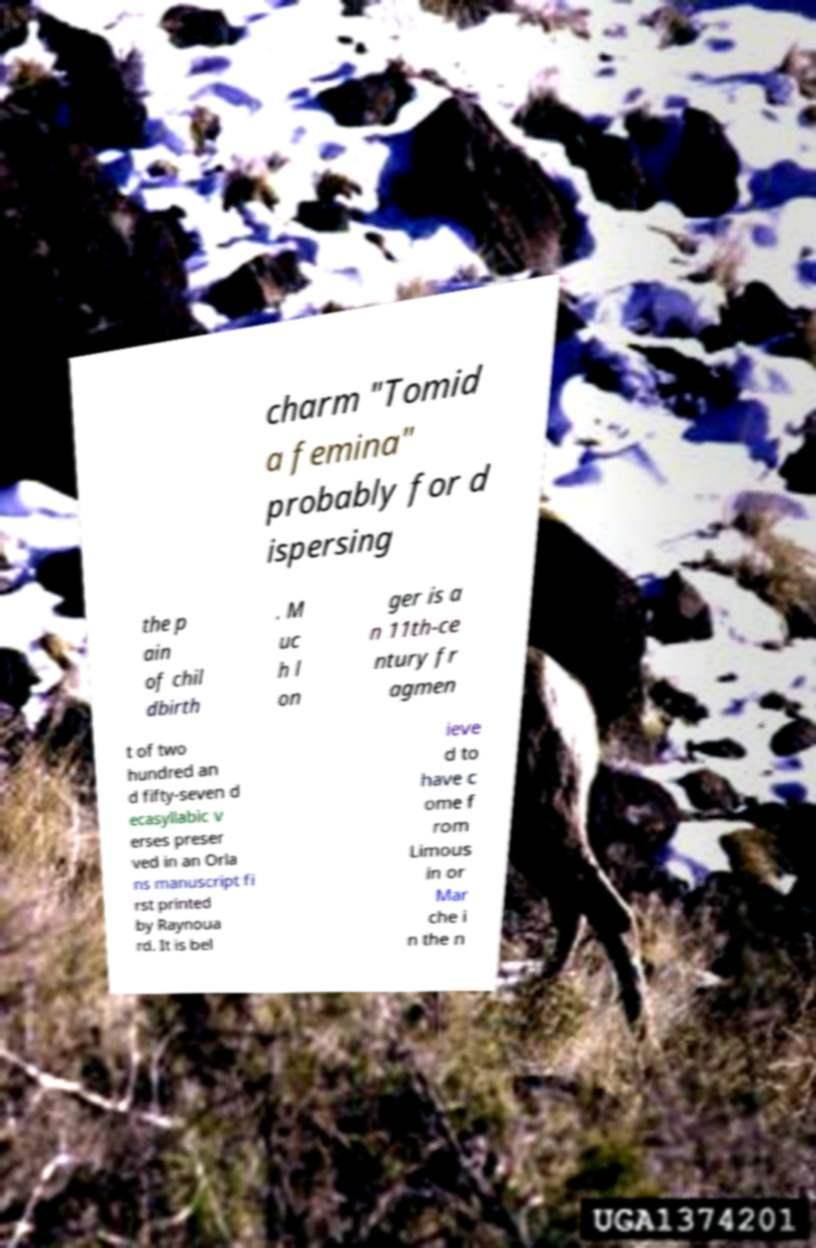Can you read and provide the text displayed in the image?This photo seems to have some interesting text. Can you extract and type it out for me? charm "Tomid a femina" probably for d ispersing the p ain of chil dbirth . M uc h l on ger is a n 11th-ce ntury fr agmen t of two hundred an d fifty-seven d ecasyllabic v erses preser ved in an Orla ns manuscript fi rst printed by Raynoua rd. It is bel ieve d to have c ome f rom Limous in or Mar che i n the n 